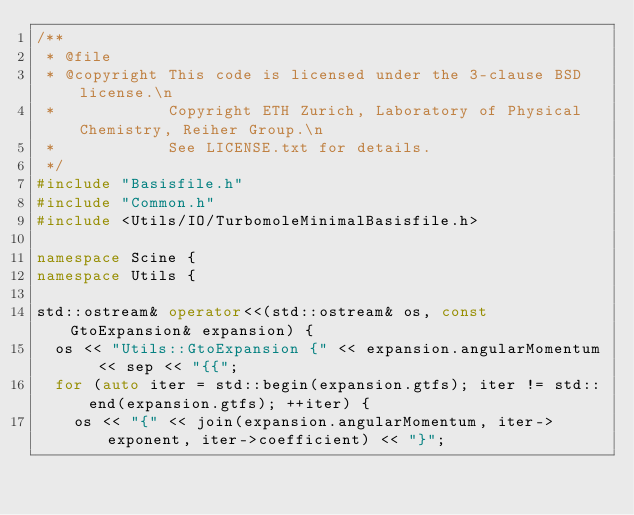Convert code to text. <code><loc_0><loc_0><loc_500><loc_500><_C++_>/**
 * @file
 * @copyright This code is licensed under the 3-clause BSD license.\n
 *            Copyright ETH Zurich, Laboratory of Physical Chemistry, Reiher Group.\n
 *            See LICENSE.txt for details.
 */
#include "Basisfile.h"
#include "Common.h"
#include <Utils/IO/TurbomoleMinimalBasisfile.h>

namespace Scine {
namespace Utils {

std::ostream& operator<<(std::ostream& os, const GtoExpansion& expansion) {
  os << "Utils::GtoExpansion {" << expansion.angularMomentum << sep << "{{";
  for (auto iter = std::begin(expansion.gtfs); iter != std::end(expansion.gtfs); ++iter) {
    os << "{" << join(expansion.angularMomentum, iter->exponent, iter->coefficient) << "}";
</code> 